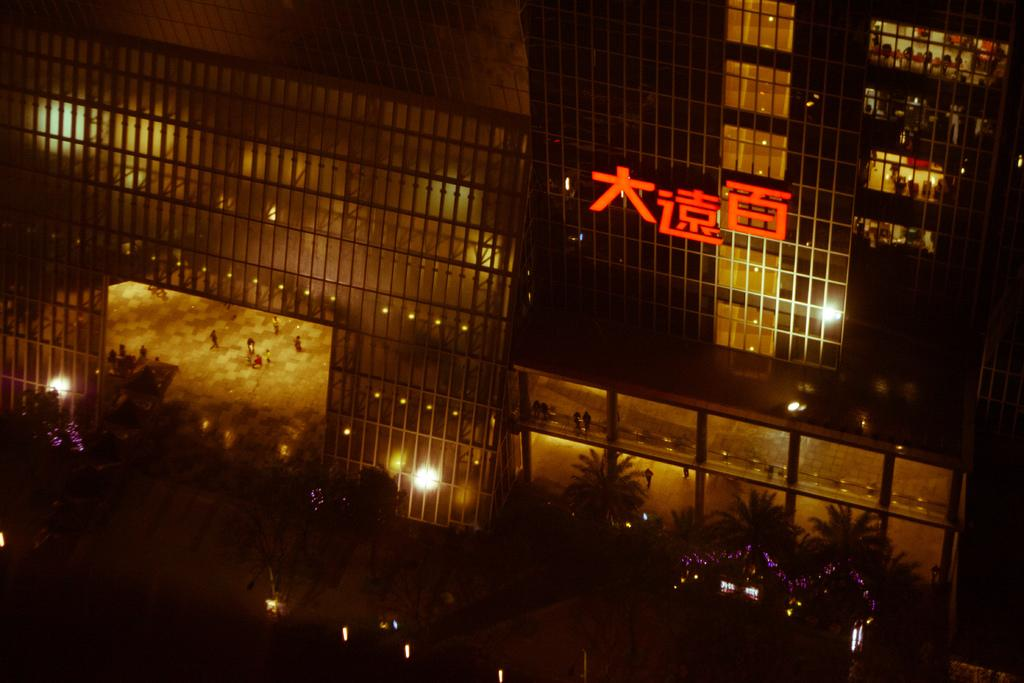What is located at the bottom of the image? There is a road at the bottom of the image. What features can be seen along the road? The road has poles and lights. What type of building is visible in the image? There is a building with glass in the image. What is in front of the building? Trees with lights are present in front of the building. What type of carpenter is working on the building in the image? There is no carpenter present in the image, nor is there any indication of construction or renovation work being done on the building. 